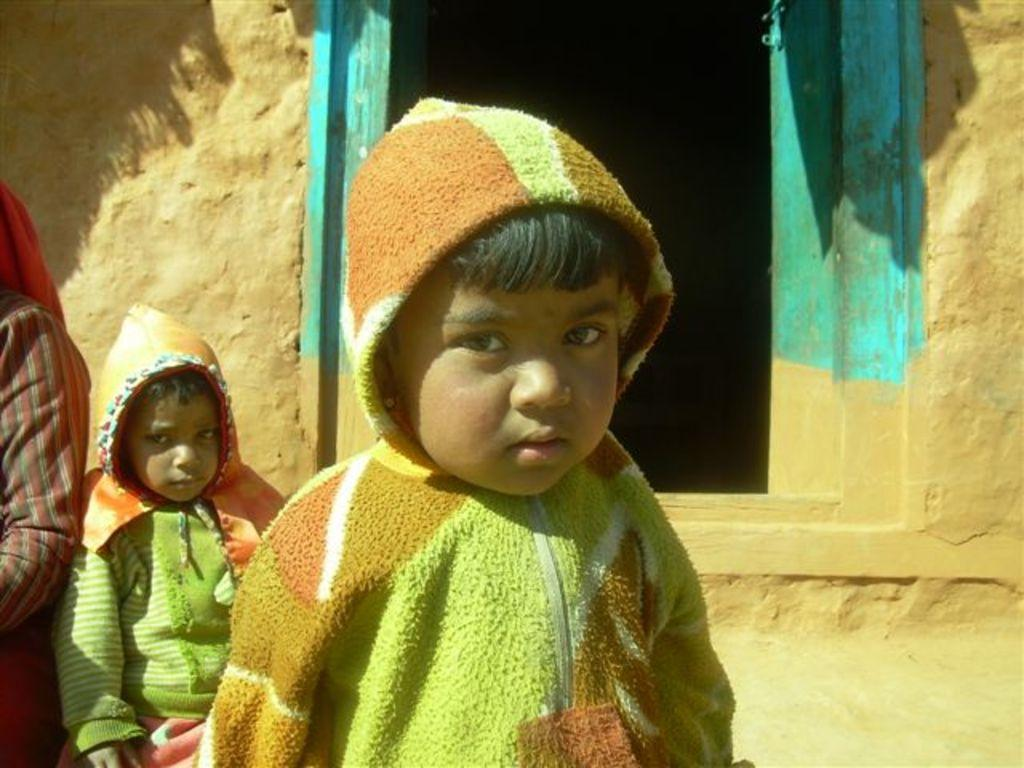Who is present in the image? There are kids in the image. What are the kids wearing? The kids are wearing sweaters. Can you describe the background of the image? There is a person, a wall, and a door in the background of the image. What type of chain can be seen in the image? There is no chain present in the image. 